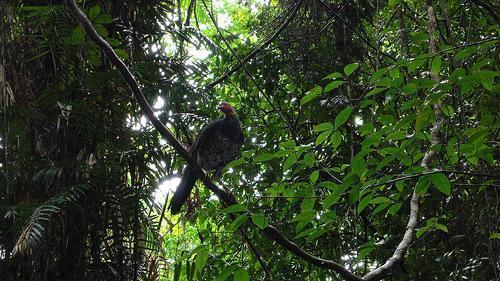How many people in the picture are not wearing glasses?
Give a very brief answer. 0. 